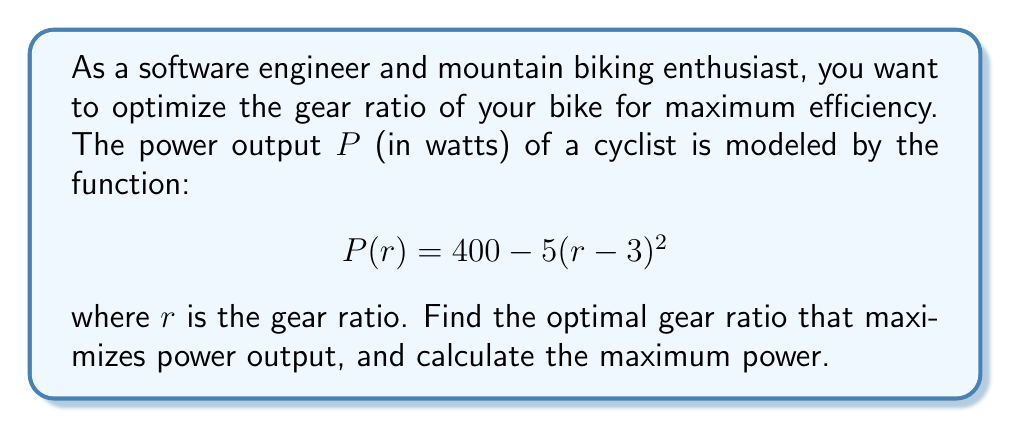Teach me how to tackle this problem. To find the optimal gear ratio that maximizes power output, we need to find the maximum of the function $P(r)$. This can be done by finding the critical point where the derivative of $P(r)$ equals zero.

Step 1: Calculate the derivative of $P(r)$.
$$\frac{dP}{dr} = -5 \cdot 2(r - 3) = -10(r - 3)$$

Step 2: Set the derivative equal to zero and solve for $r$.
$$-10(r - 3) = 0$$
$$r - 3 = 0$$
$$r = 3$$

Step 3: Verify that this critical point is a maximum by checking the second derivative.
$$\frac{d^2P}{dr^2} = -10$$
Since the second derivative is negative, the critical point is a maximum.

Step 4: Calculate the maximum power output by plugging $r = 3$ into the original function.
$$P(3) = 400 - 5(3 - 3)^2 = 400 - 5(0)^2 = 400$$

Therefore, the optimal gear ratio is 3, and the maximum power output is 400 watts.
Answer: Optimal gear ratio: 3; Maximum power: 400 watts 